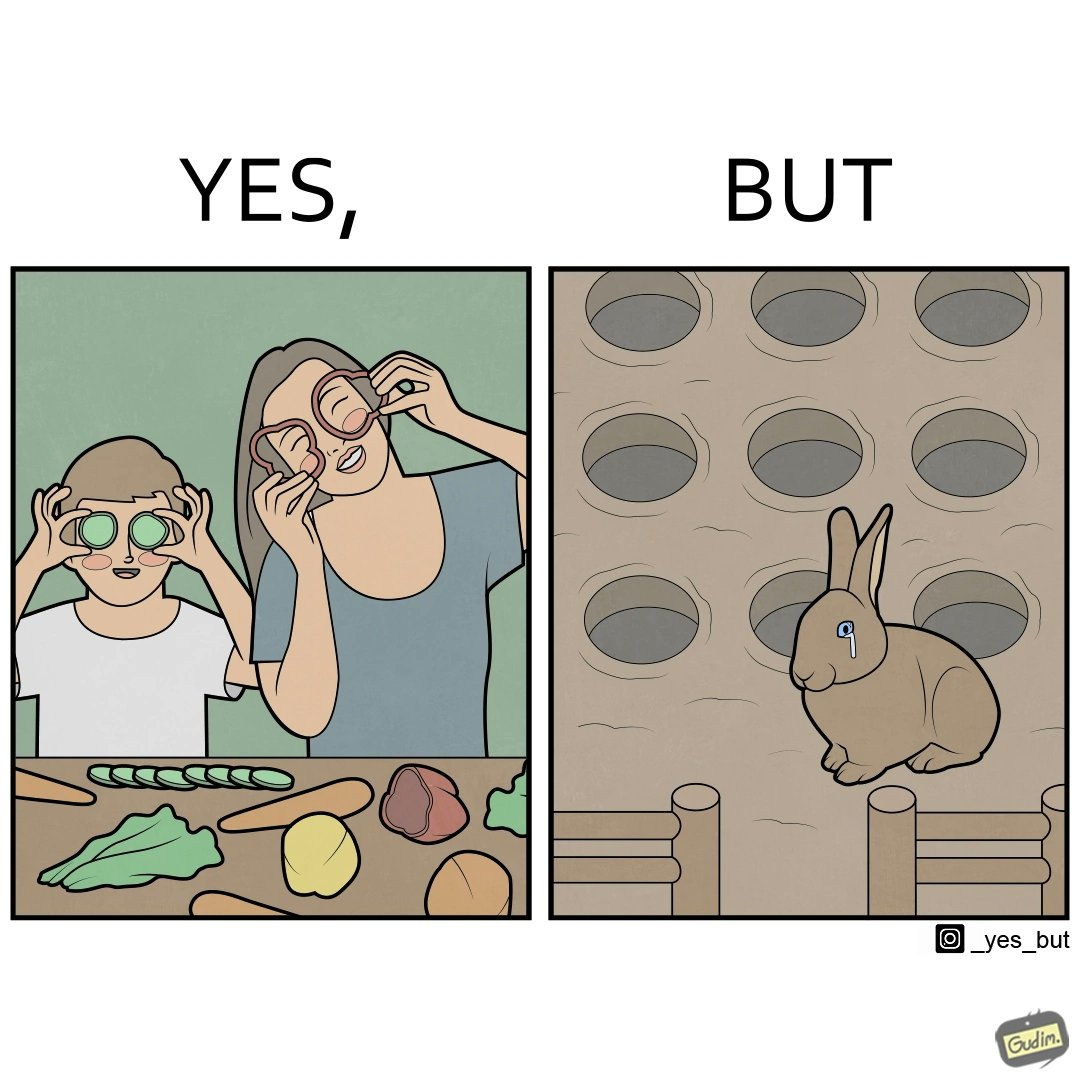What makes this image funny or satirical? The images are ironic since they show how on one hand humans choose to play with and waste foods like vegetables while the animals are unable to eat enough food and end up starving due to lack of food 